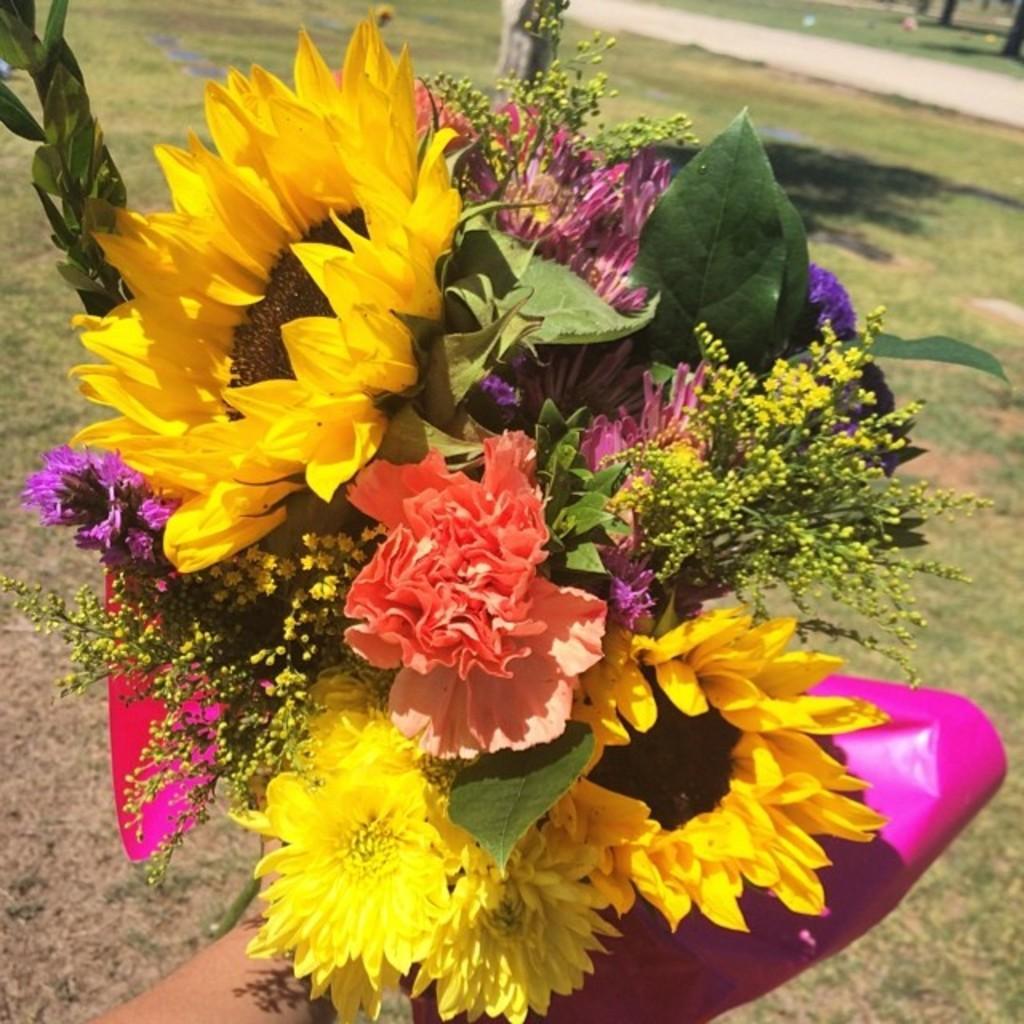In one or two sentences, can you explain what this image depicts? In this picture we can see a person holding a bouquet. At the bottom there is grass. The background is blurred. 